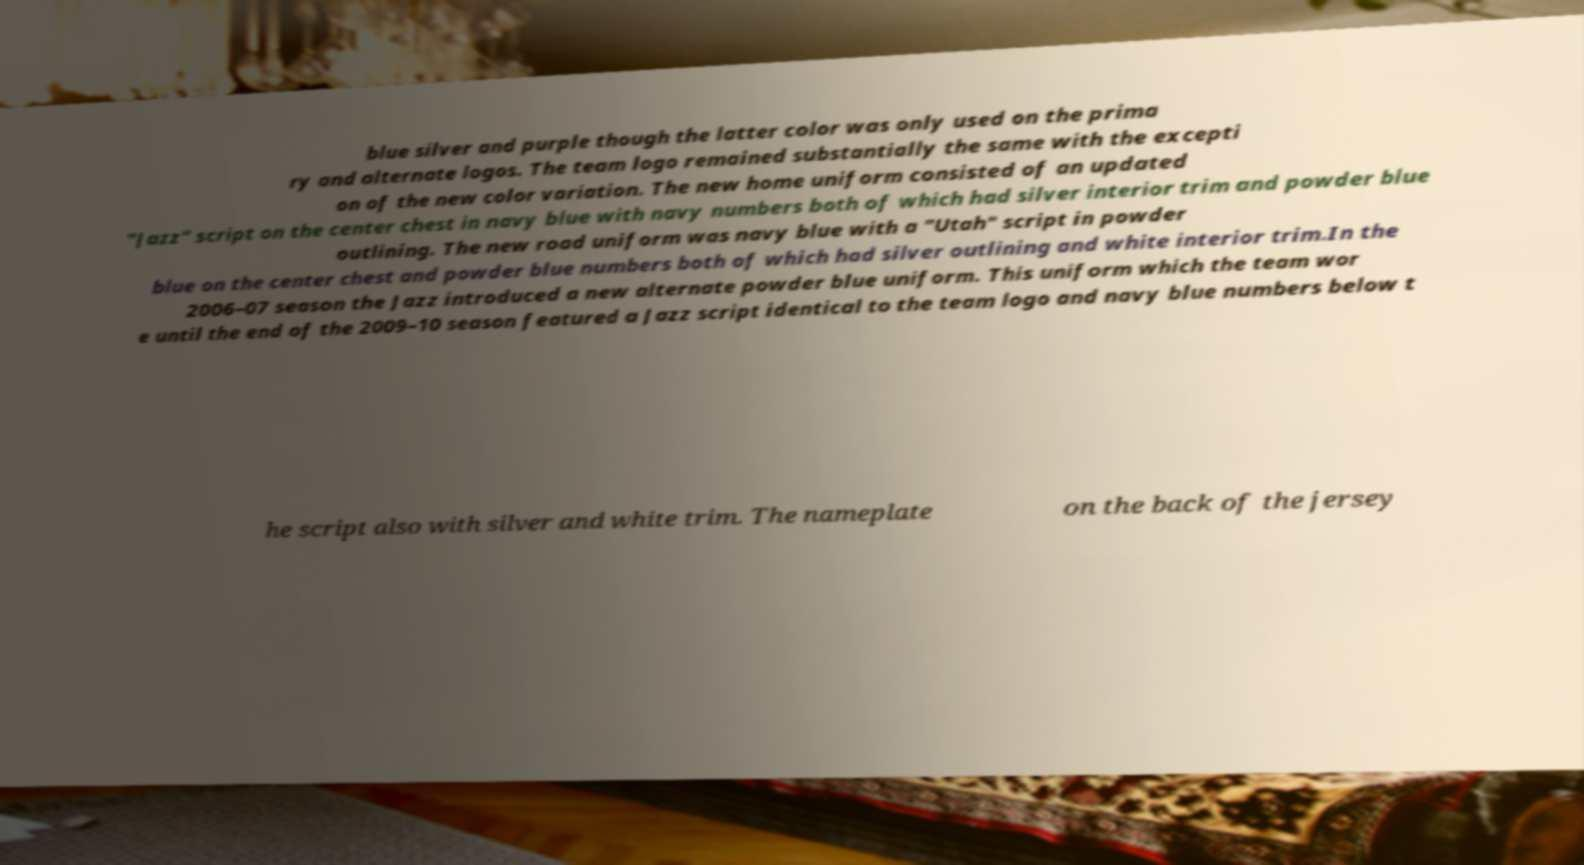For documentation purposes, I need the text within this image transcribed. Could you provide that? blue silver and purple though the latter color was only used on the prima ry and alternate logos. The team logo remained substantially the same with the excepti on of the new color variation. The new home uniform consisted of an updated "Jazz" script on the center chest in navy blue with navy numbers both of which had silver interior trim and powder blue outlining. The new road uniform was navy blue with a "Utah" script in powder blue on the center chest and powder blue numbers both of which had silver outlining and white interior trim.In the 2006–07 season the Jazz introduced a new alternate powder blue uniform. This uniform which the team wor e until the end of the 2009–10 season featured a Jazz script identical to the team logo and navy blue numbers below t he script also with silver and white trim. The nameplate on the back of the jersey 